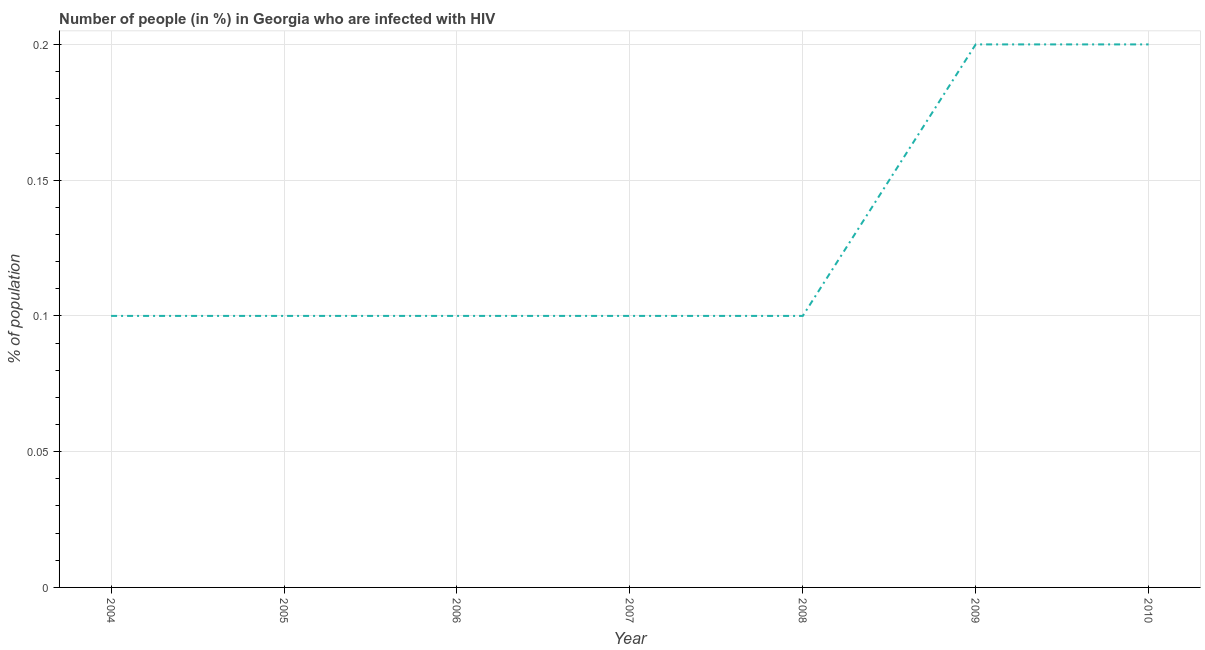Across all years, what is the maximum number of people infected with hiv?
Your response must be concise. 0.2. Across all years, what is the minimum number of people infected with hiv?
Give a very brief answer. 0.1. What is the sum of the number of people infected with hiv?
Provide a succinct answer. 0.9. What is the average number of people infected with hiv per year?
Make the answer very short. 0.13. What is the median number of people infected with hiv?
Offer a terse response. 0.1. Is the difference between the number of people infected with hiv in 2004 and 2008 greater than the difference between any two years?
Your response must be concise. No. What is the difference between the highest and the second highest number of people infected with hiv?
Make the answer very short. 0. What is the difference between the highest and the lowest number of people infected with hiv?
Your response must be concise. 0.1. How many lines are there?
Your answer should be compact. 1. What is the difference between two consecutive major ticks on the Y-axis?
Give a very brief answer. 0.05. Are the values on the major ticks of Y-axis written in scientific E-notation?
Your answer should be compact. No. Does the graph contain any zero values?
Provide a short and direct response. No. Does the graph contain grids?
Offer a very short reply. Yes. What is the title of the graph?
Your response must be concise. Number of people (in %) in Georgia who are infected with HIV. What is the label or title of the X-axis?
Provide a succinct answer. Year. What is the label or title of the Y-axis?
Provide a succinct answer. % of population. What is the % of population in 2004?
Offer a very short reply. 0.1. What is the % of population of 2006?
Give a very brief answer. 0.1. What is the % of population in 2007?
Your response must be concise. 0.1. What is the % of population in 2009?
Provide a succinct answer. 0.2. What is the difference between the % of population in 2004 and 2006?
Give a very brief answer. 0. What is the difference between the % of population in 2004 and 2008?
Your answer should be very brief. 0. What is the difference between the % of population in 2005 and 2007?
Your response must be concise. 0. What is the difference between the % of population in 2005 and 2010?
Provide a short and direct response. -0.1. What is the difference between the % of population in 2007 and 2008?
Offer a terse response. 0. What is the difference between the % of population in 2008 and 2009?
Your response must be concise. -0.1. What is the difference between the % of population in 2008 and 2010?
Your answer should be very brief. -0.1. What is the difference between the % of population in 2009 and 2010?
Your response must be concise. 0. What is the ratio of the % of population in 2004 to that in 2005?
Provide a short and direct response. 1. What is the ratio of the % of population in 2004 to that in 2008?
Offer a terse response. 1. What is the ratio of the % of population in 2004 to that in 2009?
Your answer should be very brief. 0.5. What is the ratio of the % of population in 2004 to that in 2010?
Make the answer very short. 0.5. What is the ratio of the % of population in 2005 to that in 2007?
Provide a succinct answer. 1. What is the ratio of the % of population in 2005 to that in 2008?
Your answer should be very brief. 1. What is the ratio of the % of population in 2006 to that in 2007?
Ensure brevity in your answer.  1. What is the ratio of the % of population in 2006 to that in 2008?
Ensure brevity in your answer.  1. What is the ratio of the % of population in 2006 to that in 2009?
Provide a short and direct response. 0.5. What is the ratio of the % of population in 2006 to that in 2010?
Ensure brevity in your answer.  0.5. What is the ratio of the % of population in 2007 to that in 2010?
Your answer should be compact. 0.5. What is the ratio of the % of population in 2008 to that in 2009?
Ensure brevity in your answer.  0.5. What is the ratio of the % of population in 2008 to that in 2010?
Provide a succinct answer. 0.5. What is the ratio of the % of population in 2009 to that in 2010?
Offer a terse response. 1. 